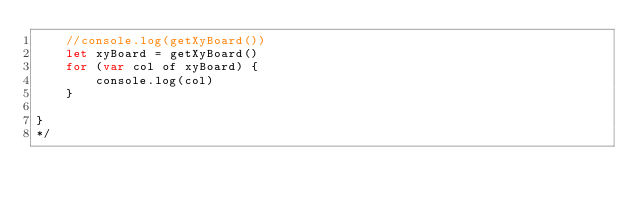Convert code to text. <code><loc_0><loc_0><loc_500><loc_500><_JavaScript_>    //console.log(getXyBoard())
    let xyBoard = getXyBoard()
    for (var col of xyBoard) {
        console.log(col)
    }

}
*/</code> 